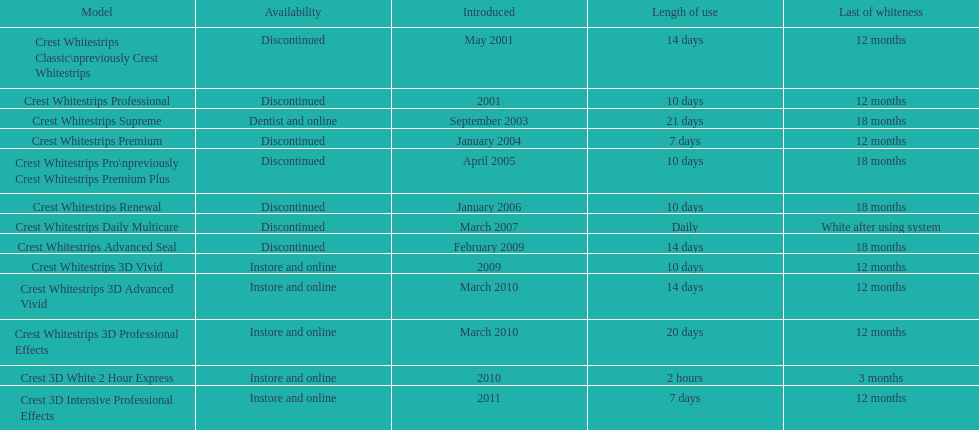Does the crest white strips classic last at least one year? Yes. 